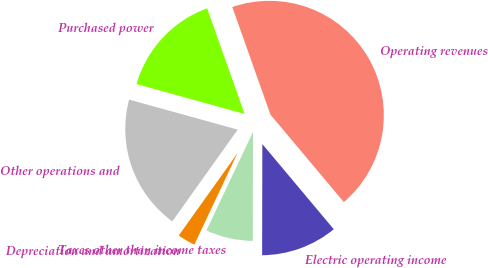Convert chart to OTSL. <chart><loc_0><loc_0><loc_500><loc_500><pie_chart><fcel>Operating revenues<fcel>Purchased power<fcel>Other operations and<fcel>Depreciation and amortization<fcel>Taxes other than income taxes<fcel>Electric operating income<nl><fcel>44.31%<fcel>15.28%<fcel>19.43%<fcel>2.84%<fcel>6.99%<fcel>11.14%<nl></chart> 